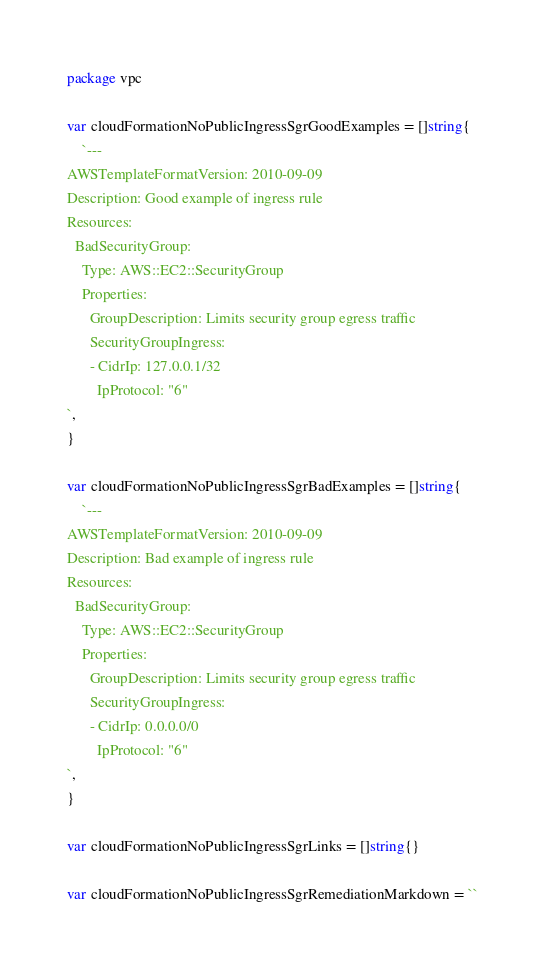<code> <loc_0><loc_0><loc_500><loc_500><_Go_>package vpc

var cloudFormationNoPublicIngressSgrGoodExamples = []string{
	`---
AWSTemplateFormatVersion: 2010-09-09
Description: Good example of ingress rule
Resources:
  BadSecurityGroup:
    Type: AWS::EC2::SecurityGroup
    Properties:
      GroupDescription: Limits security group egress traffic
      SecurityGroupIngress:
      - CidrIp: 127.0.0.1/32
        IpProtocol: "6"
`,
}

var cloudFormationNoPublicIngressSgrBadExamples = []string{
	`---
AWSTemplateFormatVersion: 2010-09-09
Description: Bad example of ingress rule
Resources:
  BadSecurityGroup:
    Type: AWS::EC2::SecurityGroup
    Properties:
      GroupDescription: Limits security group egress traffic
      SecurityGroupIngress:
      - CidrIp: 0.0.0.0/0
        IpProtocol: "6"
`,
}

var cloudFormationNoPublicIngressSgrLinks = []string{}

var cloudFormationNoPublicIngressSgrRemediationMarkdown = ``
</code> 